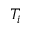Convert formula to latex. <formula><loc_0><loc_0><loc_500><loc_500>T _ { i }</formula> 